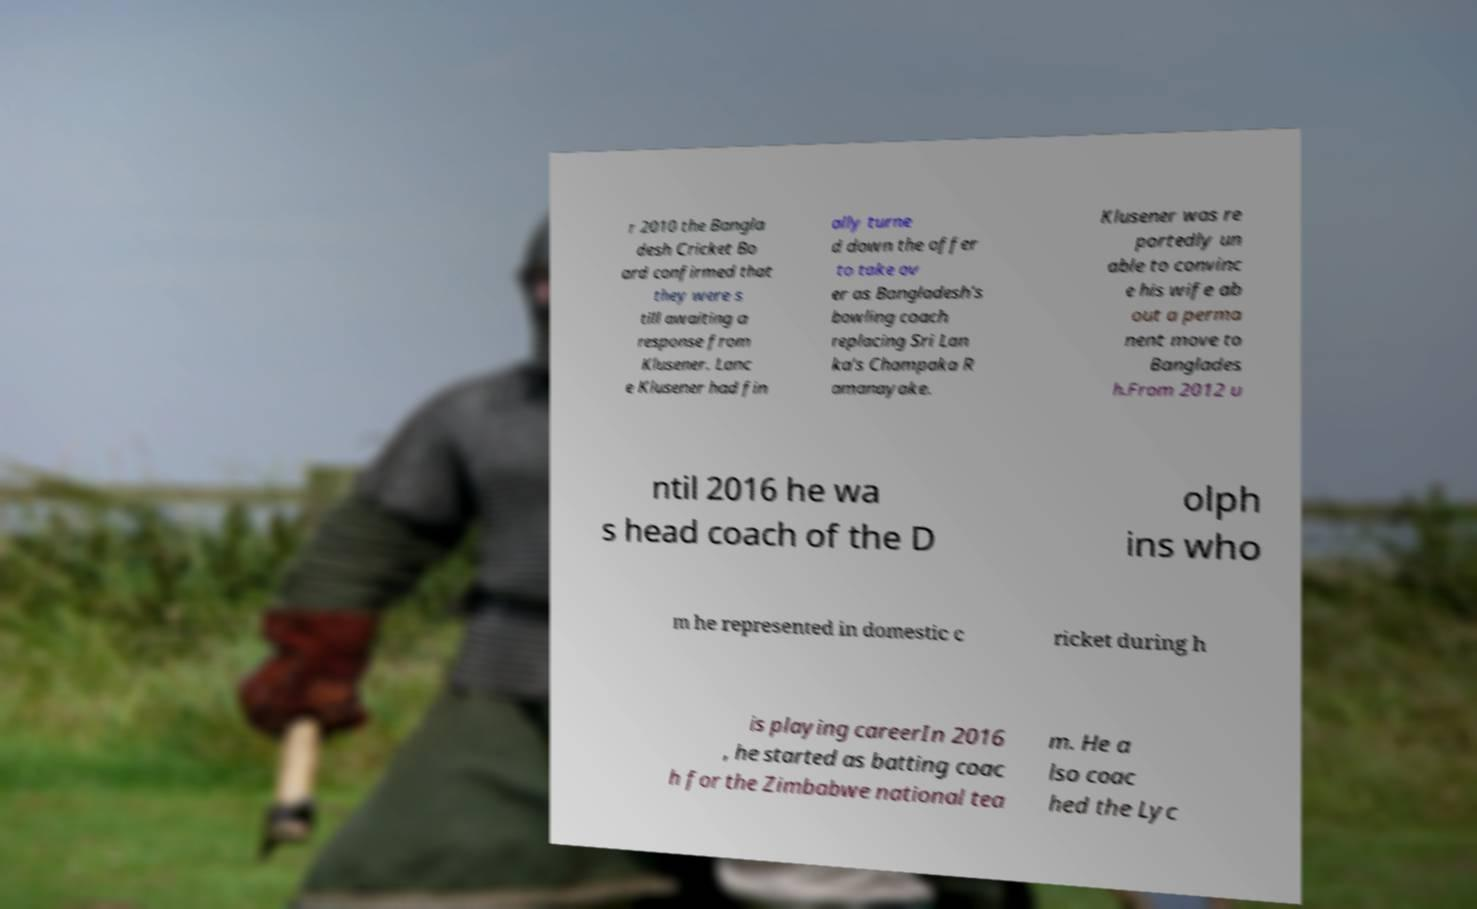There's text embedded in this image that I need extracted. Can you transcribe it verbatim? r 2010 the Bangla desh Cricket Bo ard confirmed that they were s till awaiting a response from Klusener. Lanc e Klusener had fin ally turne d down the offer to take ov er as Bangladesh's bowling coach replacing Sri Lan ka's Champaka R amanayake. Klusener was re portedly un able to convinc e his wife ab out a perma nent move to Banglades h.From 2012 u ntil 2016 he wa s head coach of the D olph ins who m he represented in domestic c ricket during h is playing careerIn 2016 , he started as batting coac h for the Zimbabwe national tea m. He a lso coac hed the Lyc 